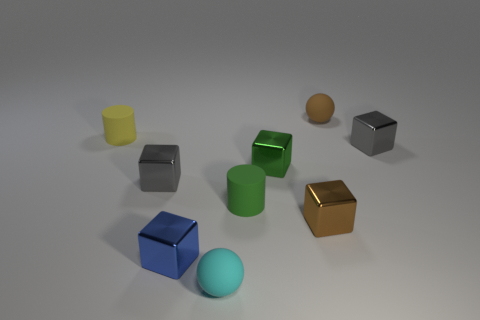There is a cube to the right of the small brown rubber thing; what is its size?
Provide a succinct answer. Small. There is a yellow cylinder to the left of the gray thing to the left of the green shiny cube; how many yellow matte things are to the right of it?
Provide a succinct answer. 0. Are there any tiny metal things on the left side of the small brown shiny block?
Keep it short and to the point. Yes. What number of other things are there of the same size as the brown rubber ball?
Offer a terse response. 8. What material is the object that is in front of the green rubber cylinder and on the right side of the cyan sphere?
Offer a very short reply. Metal. Do the tiny brown thing that is on the right side of the tiny brown metal cube and the tiny rubber thing that is in front of the blue thing have the same shape?
Give a very brief answer. Yes. The blue metallic object that is to the left of the small rubber cylinder right of the small cyan sphere left of the small brown rubber thing is what shape?
Keep it short and to the point. Cube. How many other objects are there of the same shape as the yellow object?
Your answer should be very brief. 1. What is the color of the other ball that is the same size as the brown matte ball?
Your answer should be compact. Cyan. How many cylinders are either small brown metal objects or tiny shiny objects?
Make the answer very short. 0. 